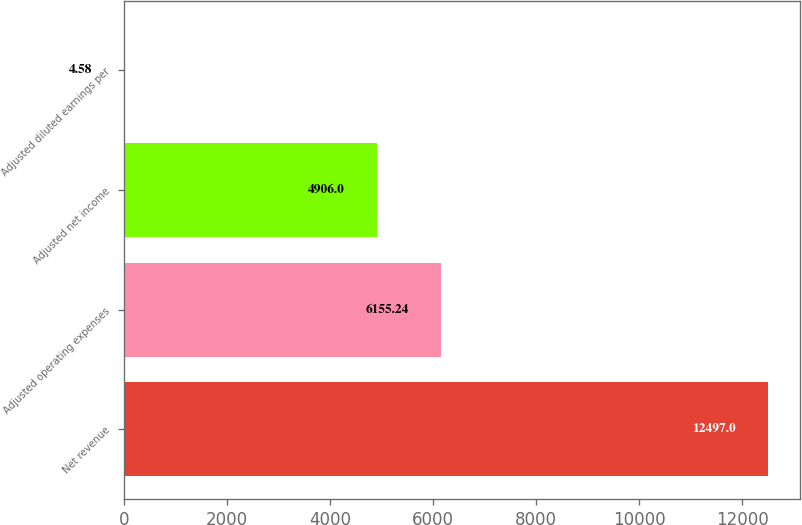<chart> <loc_0><loc_0><loc_500><loc_500><bar_chart><fcel>Net revenue<fcel>Adjusted operating expenses<fcel>Adjusted net income<fcel>Adjusted diluted earnings per<nl><fcel>12497<fcel>6155.24<fcel>4906<fcel>4.58<nl></chart> 